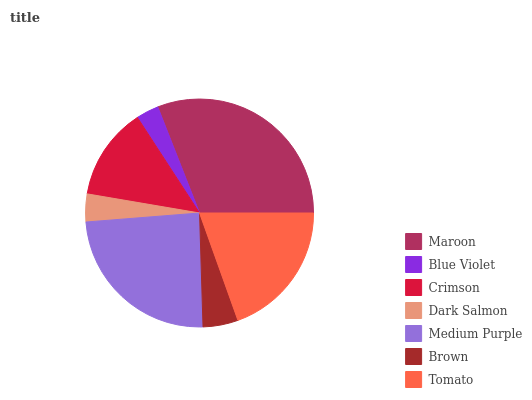Is Blue Violet the minimum?
Answer yes or no. Yes. Is Maroon the maximum?
Answer yes or no. Yes. Is Crimson the minimum?
Answer yes or no. No. Is Crimson the maximum?
Answer yes or no. No. Is Crimson greater than Blue Violet?
Answer yes or no. Yes. Is Blue Violet less than Crimson?
Answer yes or no. Yes. Is Blue Violet greater than Crimson?
Answer yes or no. No. Is Crimson less than Blue Violet?
Answer yes or no. No. Is Crimson the high median?
Answer yes or no. Yes. Is Crimson the low median?
Answer yes or no. Yes. Is Maroon the high median?
Answer yes or no. No. Is Brown the low median?
Answer yes or no. No. 